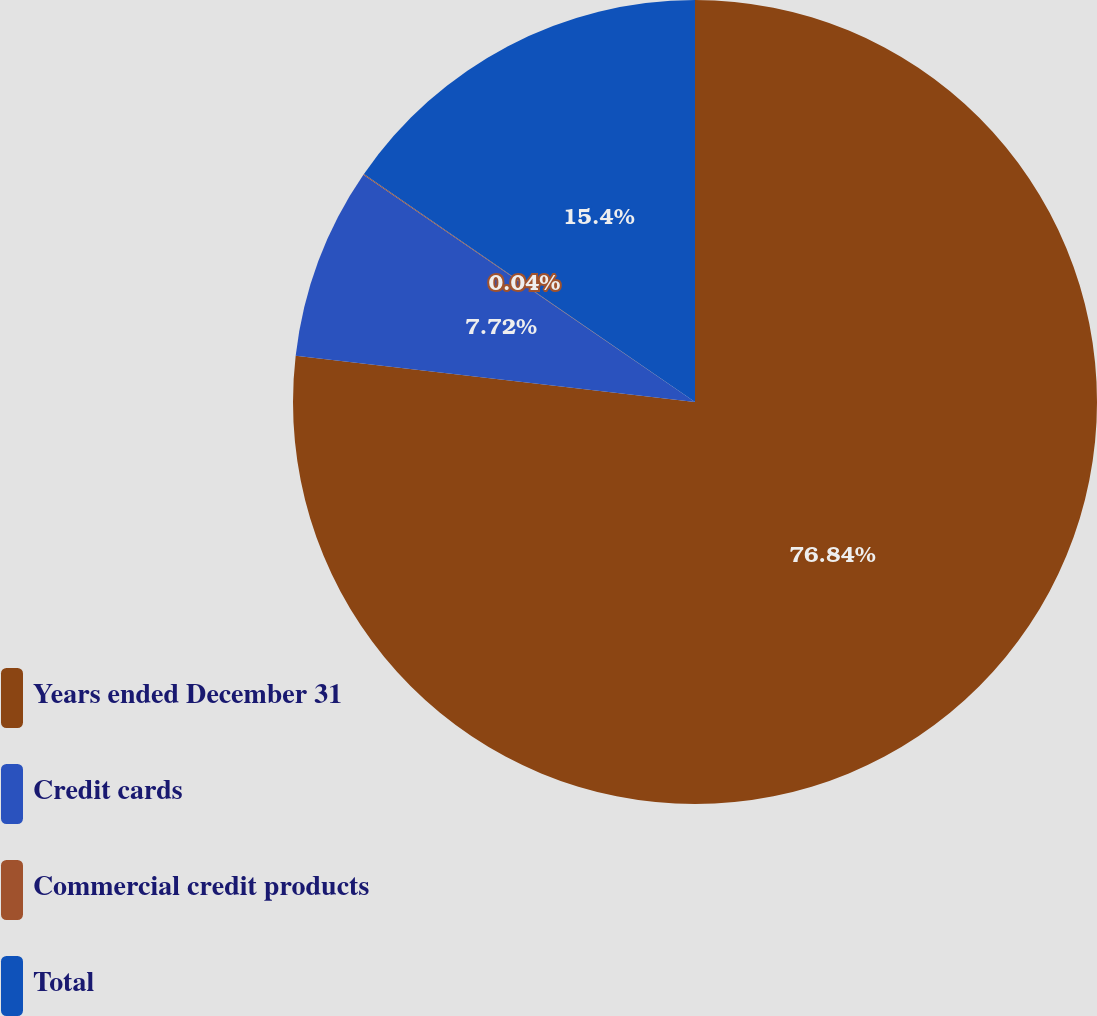Convert chart to OTSL. <chart><loc_0><loc_0><loc_500><loc_500><pie_chart><fcel>Years ended December 31<fcel>Credit cards<fcel>Commercial credit products<fcel>Total<nl><fcel>76.84%<fcel>7.72%<fcel>0.04%<fcel>15.4%<nl></chart> 